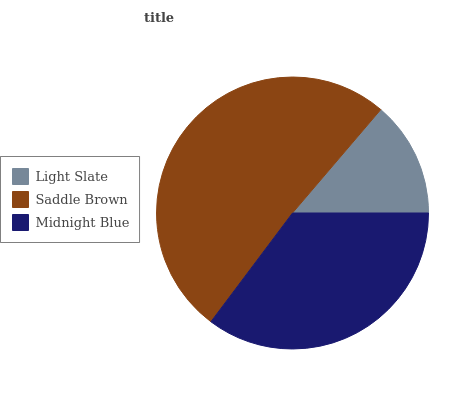Is Light Slate the minimum?
Answer yes or no. Yes. Is Saddle Brown the maximum?
Answer yes or no. Yes. Is Midnight Blue the minimum?
Answer yes or no. No. Is Midnight Blue the maximum?
Answer yes or no. No. Is Saddle Brown greater than Midnight Blue?
Answer yes or no. Yes. Is Midnight Blue less than Saddle Brown?
Answer yes or no. Yes. Is Midnight Blue greater than Saddle Brown?
Answer yes or no. No. Is Saddle Brown less than Midnight Blue?
Answer yes or no. No. Is Midnight Blue the high median?
Answer yes or no. Yes. Is Midnight Blue the low median?
Answer yes or no. Yes. Is Saddle Brown the high median?
Answer yes or no. No. Is Light Slate the low median?
Answer yes or no. No. 